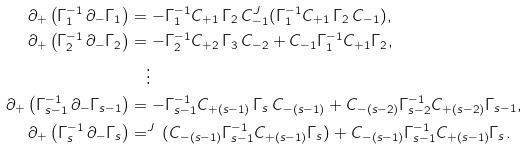Convert formula to latex. <formula><loc_0><loc_0><loc_500><loc_500>\partial _ { + } \left ( \Gamma _ { 1 } ^ { - 1 } \, \partial _ { - } \Gamma _ { 1 } \right ) & = - \Gamma _ { 1 } ^ { - 1 } C _ { + 1 } \, \Gamma _ { 2 } \, C _ { - 1 } ^ { J \, } ( \Gamma _ { 1 } ^ { - 1 } C _ { + 1 } \, \Gamma _ { 2 } \, C _ { - 1 } ) , \\ \partial _ { + } \left ( \Gamma _ { 2 } ^ { - 1 } \, \partial _ { - } \Gamma _ { 2 } \right ) & = - \Gamma _ { 2 } ^ { - 1 } C _ { + 2 } \, \Gamma _ { 3 } \, C _ { - 2 } + C _ { - 1 } \Gamma _ { 1 } ^ { - 1 } C _ { + 1 } \Gamma _ { 2 } , \\ & \quad \vdots \\ \partial _ { + } \left ( \Gamma _ { s - 1 } ^ { - 1 } \, \partial _ { - } \Gamma _ { s - 1 } \right ) & = - \Gamma _ { s - 1 } ^ { - 1 } C _ { + ( s - 1 ) } \, \Gamma _ { s } \, C _ { - ( s - 1 ) } + C _ { - ( s - 2 ) } \Gamma _ { s - 2 } ^ { - 1 } C _ { + ( s - 2 ) } \Gamma _ { s - 1 } , \\ \partial _ { + } \left ( \Gamma _ { s } ^ { - 1 } \, \partial _ { - } \Gamma _ { s } \right ) & = ^ { J \, } ( C _ { - ( s - 1 ) } \Gamma _ { s - 1 } ^ { - 1 } C _ { + ( s - 1 ) } \Gamma _ { s } ) + C _ { - ( s - 1 ) } \Gamma _ { s - 1 } ^ { - 1 } C _ { + ( s - 1 ) } \Gamma _ { s } .</formula> 